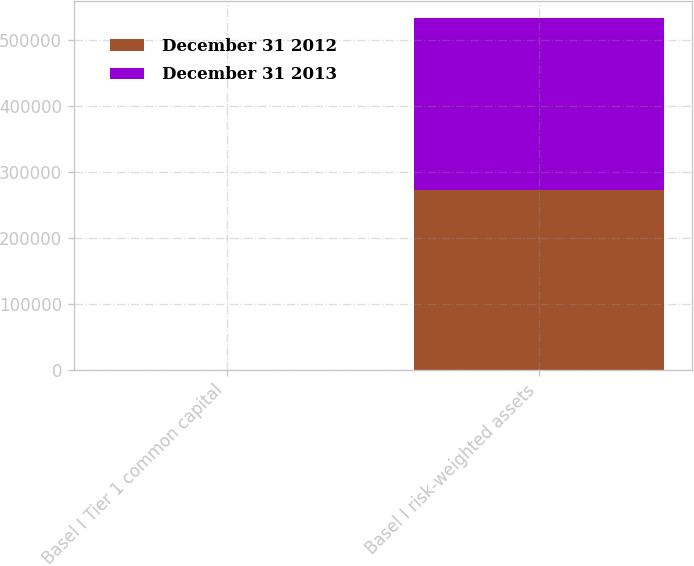Convert chart. <chart><loc_0><loc_0><loc_500><loc_500><stacked_bar_chart><ecel><fcel>Basel I Tier 1 common capital<fcel>Basel I risk-weighted assets<nl><fcel>December 31 2012<fcel>10.5<fcel>272169<nl><fcel>December 31 2013<fcel>9.6<fcel>260847<nl></chart> 